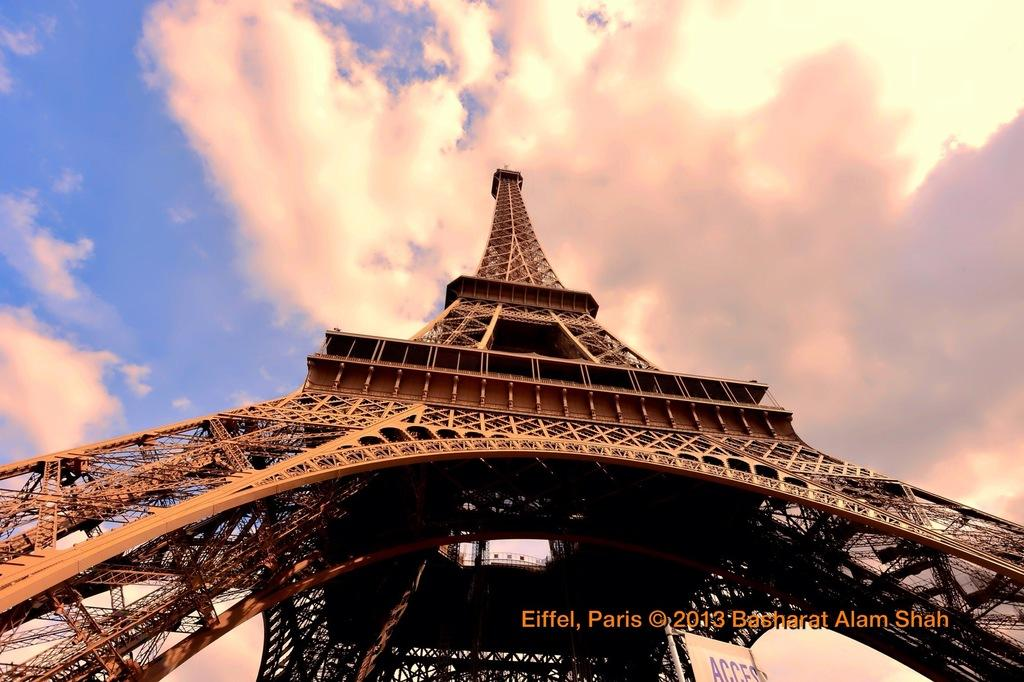What is the main subject of the image? The main subject of the image is the Eiffel Tower, which is located in the center of the image. What can be seen in the background of the image? Sky is visible in the background of the image. Are there any weather conditions depicted in the image? Yes, there are clouds in the sky, which suggests a partly cloudy day. What type of glove is being used to explain the theory in the image? There is no glove or theory present in the image; it only features the Eiffel Tower and the sky. 